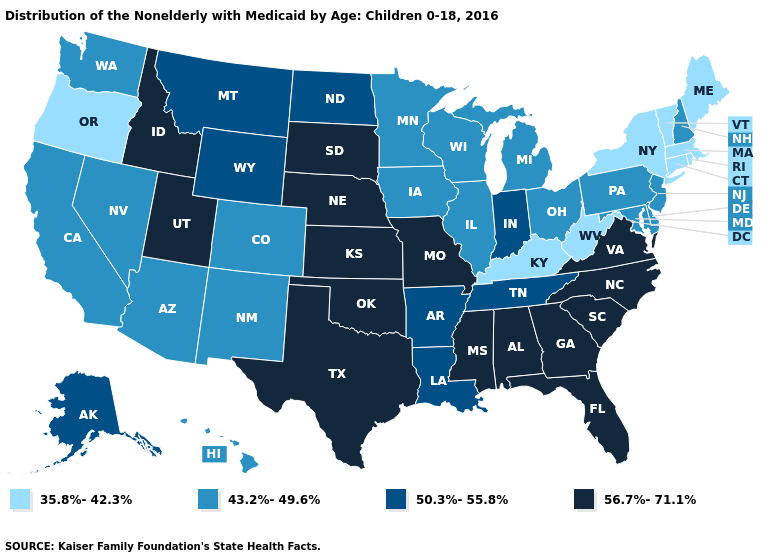What is the value of North Dakota?
Keep it brief. 50.3%-55.8%. Does Pennsylvania have the lowest value in the USA?
Keep it brief. No. Does the map have missing data?
Concise answer only. No. Among the states that border California , does Oregon have the highest value?
Answer briefly. No. Name the states that have a value in the range 56.7%-71.1%?
Write a very short answer. Alabama, Florida, Georgia, Idaho, Kansas, Mississippi, Missouri, Nebraska, North Carolina, Oklahoma, South Carolina, South Dakota, Texas, Utah, Virginia. What is the value of California?
Be succinct. 43.2%-49.6%. Name the states that have a value in the range 50.3%-55.8%?
Give a very brief answer. Alaska, Arkansas, Indiana, Louisiana, Montana, North Dakota, Tennessee, Wyoming. What is the value of Nevada?
Concise answer only. 43.2%-49.6%. How many symbols are there in the legend?
Write a very short answer. 4. What is the value of Connecticut?
Keep it brief. 35.8%-42.3%. Among the states that border North Carolina , which have the highest value?
Be succinct. Georgia, South Carolina, Virginia. Does New Hampshire have the highest value in the USA?
Write a very short answer. No. Is the legend a continuous bar?
Short answer required. No. What is the value of Rhode Island?
Answer briefly. 35.8%-42.3%. What is the value of Arkansas?
Quick response, please. 50.3%-55.8%. 